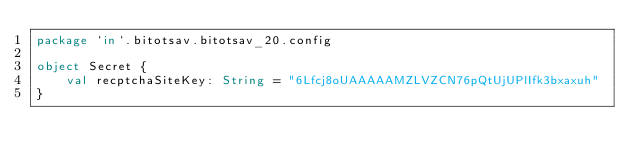Convert code to text. <code><loc_0><loc_0><loc_500><loc_500><_Kotlin_>package `in`.bitotsav.bitotsav_20.config

object Secret {
    val recptchaSiteKey: String = "6Lfcj8oUAAAAAMZLVZCN76pQtUjUPlIfk3bxaxuh"
}</code> 